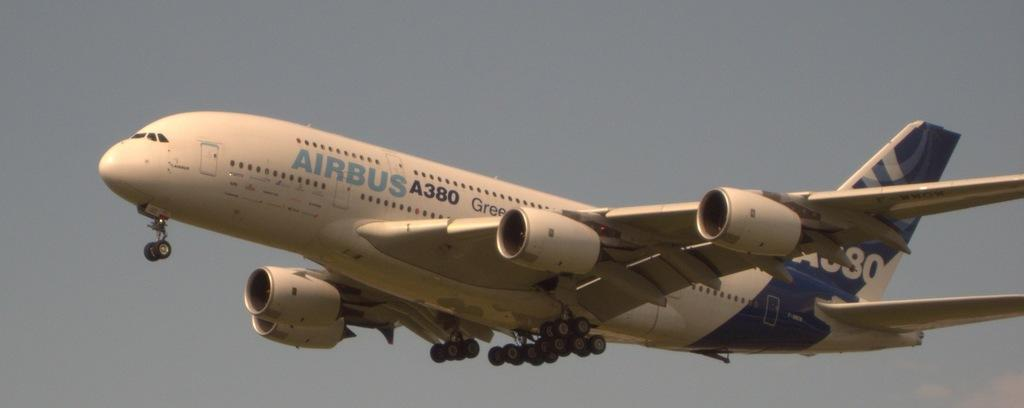<image>
Render a clear and concise summary of the photo. an Airbus A380 just after take off in the sky 